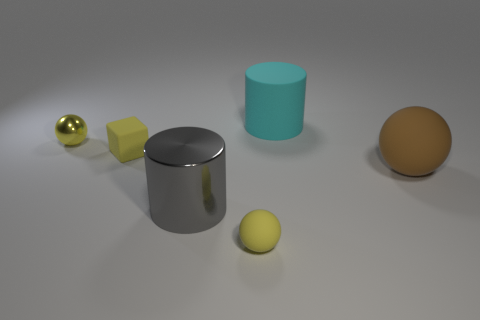There is a large thing that is in front of the brown rubber thing; what shape is it?
Offer a terse response. Cylinder. The big object to the left of the rubber object in front of the gray shiny cylinder is what color?
Provide a short and direct response. Gray. There is a big rubber thing in front of the block; is it the same shape as the large thing behind the yellow metallic sphere?
Your answer should be compact. No. There is a cyan object that is the same size as the shiny cylinder; what is its shape?
Keep it short and to the point. Cylinder. What color is the block that is made of the same material as the big cyan object?
Offer a very short reply. Yellow. Does the cyan object have the same shape as the big object on the left side of the big cyan cylinder?
Make the answer very short. Yes. There is a tiny block that is the same color as the tiny rubber sphere; what material is it?
Your answer should be compact. Rubber. There is a cyan cylinder that is the same size as the gray shiny thing; what material is it?
Keep it short and to the point. Rubber. Are there any tiny spheres of the same color as the large matte sphere?
Make the answer very short. No. What is the shape of the object that is in front of the big ball and on the left side of the small rubber sphere?
Your answer should be compact. Cylinder. 